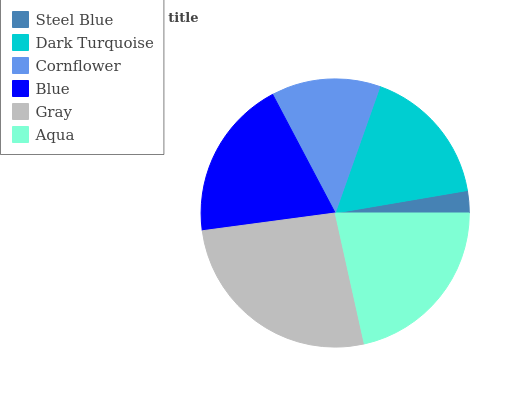Is Steel Blue the minimum?
Answer yes or no. Yes. Is Gray the maximum?
Answer yes or no. Yes. Is Dark Turquoise the minimum?
Answer yes or no. No. Is Dark Turquoise the maximum?
Answer yes or no. No. Is Dark Turquoise greater than Steel Blue?
Answer yes or no. Yes. Is Steel Blue less than Dark Turquoise?
Answer yes or no. Yes. Is Steel Blue greater than Dark Turquoise?
Answer yes or no. No. Is Dark Turquoise less than Steel Blue?
Answer yes or no. No. Is Blue the high median?
Answer yes or no. Yes. Is Dark Turquoise the low median?
Answer yes or no. Yes. Is Gray the high median?
Answer yes or no. No. Is Aqua the low median?
Answer yes or no. No. 